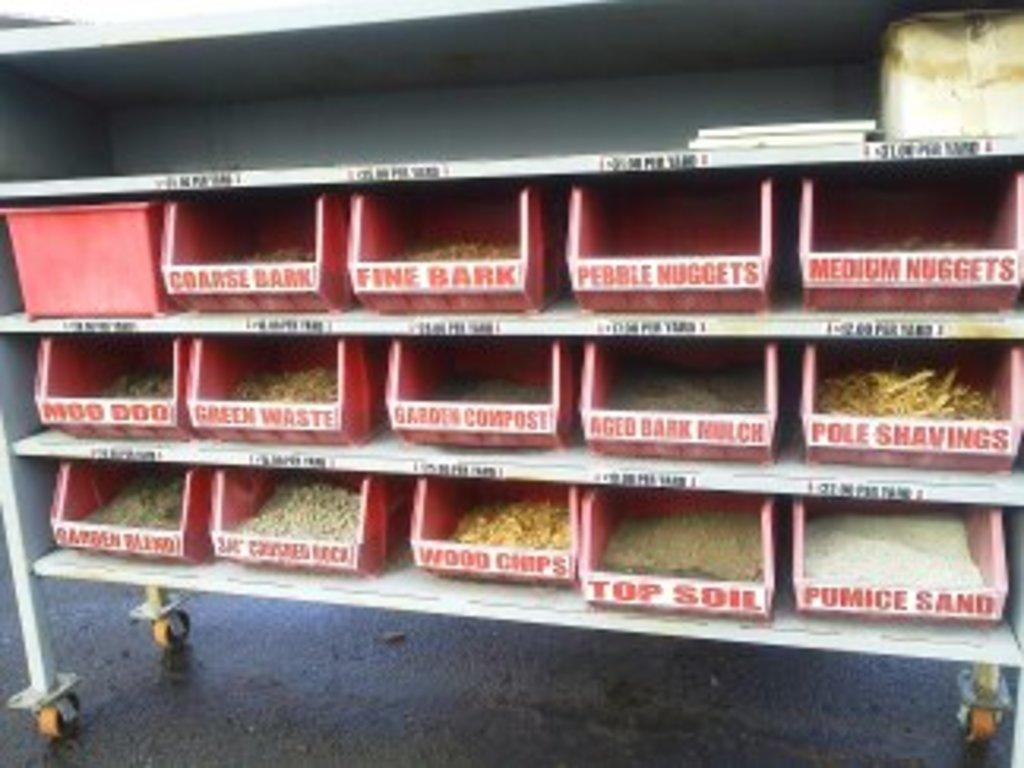What is inside the boxes that are visible in the image? There are boxes containing seeds in the image. How are the boxes arranged in the image? The boxes are placed in racks. What can be seen at the bottom of the image? There is a road visible at the bottom of the image. How many tubs of paint are visible in the image? There are no tubs of paint present in the image; it features boxes containing seeds placed in racks. What type of bottle can be seen on the road in the image? There is no bottle visible on the road in the image; it only shows a road at the bottom. 